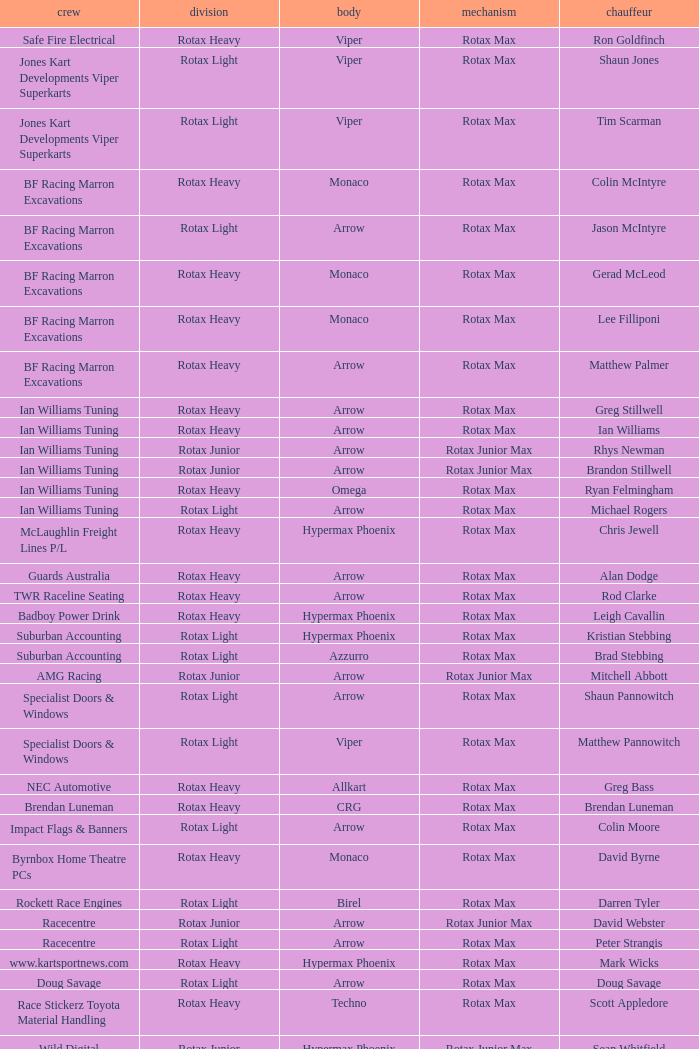Driver Shaun Jones with a viper as a chassis is in what class? Rotax Light. 